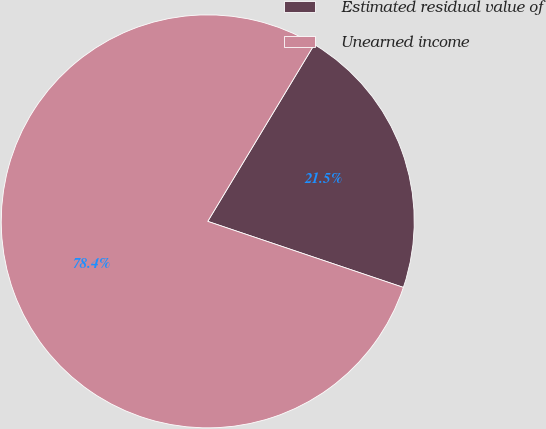Convert chart. <chart><loc_0><loc_0><loc_500><loc_500><pie_chart><fcel>Estimated residual value of<fcel>Unearned income<nl><fcel>21.55%<fcel>78.45%<nl></chart> 